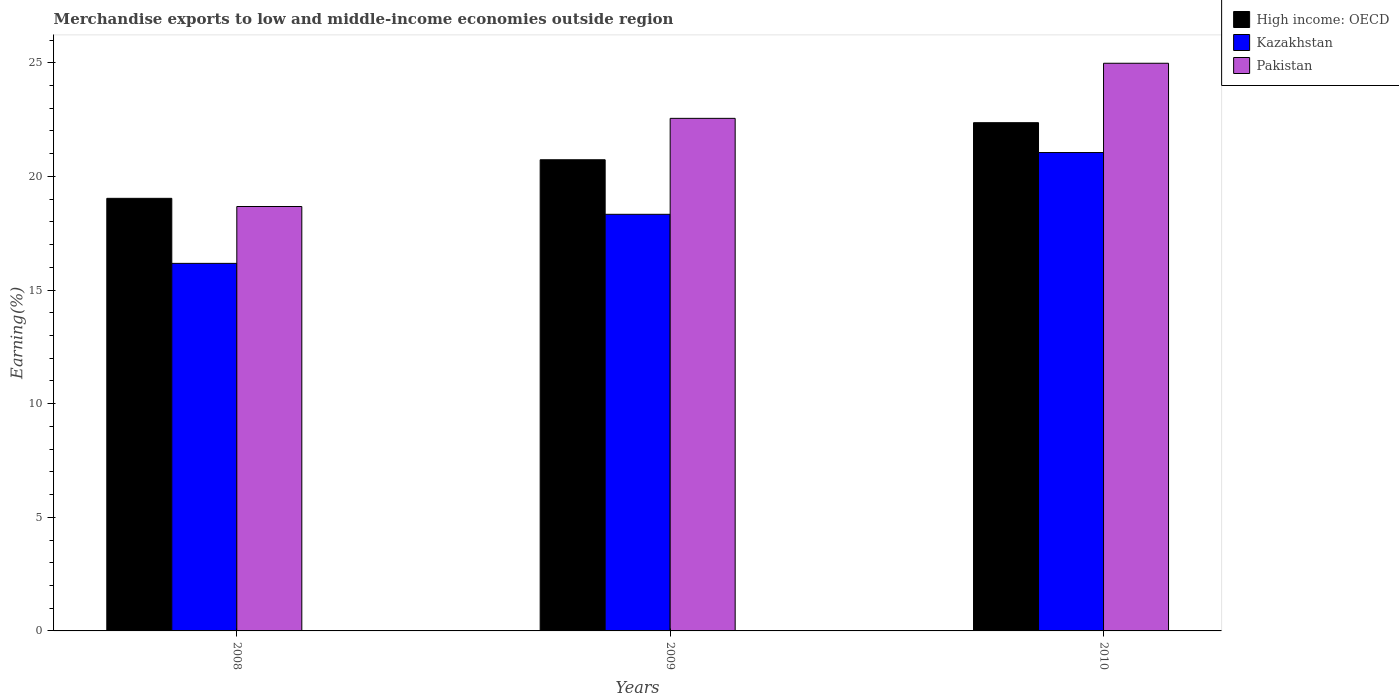How many different coloured bars are there?
Offer a terse response. 3. What is the label of the 1st group of bars from the left?
Ensure brevity in your answer.  2008. In how many cases, is the number of bars for a given year not equal to the number of legend labels?
Offer a terse response. 0. What is the percentage of amount earned from merchandise exports in Kazakhstan in 2010?
Make the answer very short. 21.05. Across all years, what is the maximum percentage of amount earned from merchandise exports in Pakistan?
Offer a very short reply. 24.98. Across all years, what is the minimum percentage of amount earned from merchandise exports in Kazakhstan?
Offer a terse response. 16.17. In which year was the percentage of amount earned from merchandise exports in Kazakhstan maximum?
Your response must be concise. 2010. What is the total percentage of amount earned from merchandise exports in Pakistan in the graph?
Provide a short and direct response. 66.21. What is the difference between the percentage of amount earned from merchandise exports in Pakistan in 2008 and that in 2009?
Offer a very short reply. -3.88. What is the difference between the percentage of amount earned from merchandise exports in Pakistan in 2010 and the percentage of amount earned from merchandise exports in Kazakhstan in 2009?
Your answer should be compact. 6.65. What is the average percentage of amount earned from merchandise exports in Pakistan per year?
Provide a succinct answer. 22.07. In the year 2008, what is the difference between the percentage of amount earned from merchandise exports in Pakistan and percentage of amount earned from merchandise exports in High income: OECD?
Keep it short and to the point. -0.36. In how many years, is the percentage of amount earned from merchandise exports in High income: OECD greater than 9 %?
Provide a succinct answer. 3. What is the ratio of the percentage of amount earned from merchandise exports in High income: OECD in 2009 to that in 2010?
Offer a terse response. 0.93. Is the percentage of amount earned from merchandise exports in High income: OECD in 2008 less than that in 2010?
Make the answer very short. Yes. What is the difference between the highest and the second highest percentage of amount earned from merchandise exports in Pakistan?
Your response must be concise. 2.42. What is the difference between the highest and the lowest percentage of amount earned from merchandise exports in High income: OECD?
Make the answer very short. 3.33. In how many years, is the percentage of amount earned from merchandise exports in Pakistan greater than the average percentage of amount earned from merchandise exports in Pakistan taken over all years?
Keep it short and to the point. 2. What does the 2nd bar from the left in 2010 represents?
Provide a short and direct response. Kazakhstan. What does the 3rd bar from the right in 2008 represents?
Your response must be concise. High income: OECD. How many bars are there?
Keep it short and to the point. 9. Are all the bars in the graph horizontal?
Offer a very short reply. No. How many years are there in the graph?
Keep it short and to the point. 3. Are the values on the major ticks of Y-axis written in scientific E-notation?
Your answer should be compact. No. Does the graph contain grids?
Your response must be concise. No. Where does the legend appear in the graph?
Offer a very short reply. Top right. How many legend labels are there?
Your answer should be compact. 3. What is the title of the graph?
Provide a short and direct response. Merchandise exports to low and middle-income economies outside region. What is the label or title of the Y-axis?
Make the answer very short. Earning(%). What is the Earning(%) of High income: OECD in 2008?
Your answer should be very brief. 19.04. What is the Earning(%) in Kazakhstan in 2008?
Keep it short and to the point. 16.17. What is the Earning(%) of Pakistan in 2008?
Offer a very short reply. 18.68. What is the Earning(%) in High income: OECD in 2009?
Make the answer very short. 20.73. What is the Earning(%) of Kazakhstan in 2009?
Offer a very short reply. 18.33. What is the Earning(%) of Pakistan in 2009?
Your response must be concise. 22.55. What is the Earning(%) in High income: OECD in 2010?
Your answer should be very brief. 22.36. What is the Earning(%) in Kazakhstan in 2010?
Your answer should be very brief. 21.05. What is the Earning(%) in Pakistan in 2010?
Offer a terse response. 24.98. Across all years, what is the maximum Earning(%) in High income: OECD?
Give a very brief answer. 22.36. Across all years, what is the maximum Earning(%) of Kazakhstan?
Provide a short and direct response. 21.05. Across all years, what is the maximum Earning(%) in Pakistan?
Your answer should be compact. 24.98. Across all years, what is the minimum Earning(%) of High income: OECD?
Provide a short and direct response. 19.04. Across all years, what is the minimum Earning(%) in Kazakhstan?
Offer a terse response. 16.17. Across all years, what is the minimum Earning(%) in Pakistan?
Give a very brief answer. 18.68. What is the total Earning(%) of High income: OECD in the graph?
Your answer should be very brief. 62.13. What is the total Earning(%) in Kazakhstan in the graph?
Offer a very short reply. 55.56. What is the total Earning(%) of Pakistan in the graph?
Your answer should be compact. 66.21. What is the difference between the Earning(%) of High income: OECD in 2008 and that in 2009?
Your answer should be compact. -1.7. What is the difference between the Earning(%) of Kazakhstan in 2008 and that in 2009?
Your answer should be very brief. -2.16. What is the difference between the Earning(%) in Pakistan in 2008 and that in 2009?
Provide a succinct answer. -3.88. What is the difference between the Earning(%) of High income: OECD in 2008 and that in 2010?
Offer a very short reply. -3.33. What is the difference between the Earning(%) of Kazakhstan in 2008 and that in 2010?
Your answer should be very brief. -4.88. What is the difference between the Earning(%) of Pakistan in 2008 and that in 2010?
Ensure brevity in your answer.  -6.3. What is the difference between the Earning(%) of High income: OECD in 2009 and that in 2010?
Make the answer very short. -1.63. What is the difference between the Earning(%) in Kazakhstan in 2009 and that in 2010?
Your answer should be compact. -2.72. What is the difference between the Earning(%) of Pakistan in 2009 and that in 2010?
Offer a very short reply. -2.42. What is the difference between the Earning(%) in High income: OECD in 2008 and the Earning(%) in Kazakhstan in 2009?
Provide a short and direct response. 0.7. What is the difference between the Earning(%) of High income: OECD in 2008 and the Earning(%) of Pakistan in 2009?
Keep it short and to the point. -3.52. What is the difference between the Earning(%) of Kazakhstan in 2008 and the Earning(%) of Pakistan in 2009?
Give a very brief answer. -6.38. What is the difference between the Earning(%) in High income: OECD in 2008 and the Earning(%) in Kazakhstan in 2010?
Ensure brevity in your answer.  -2.02. What is the difference between the Earning(%) of High income: OECD in 2008 and the Earning(%) of Pakistan in 2010?
Ensure brevity in your answer.  -5.94. What is the difference between the Earning(%) in Kazakhstan in 2008 and the Earning(%) in Pakistan in 2010?
Provide a short and direct response. -8.81. What is the difference between the Earning(%) in High income: OECD in 2009 and the Earning(%) in Kazakhstan in 2010?
Give a very brief answer. -0.32. What is the difference between the Earning(%) of High income: OECD in 2009 and the Earning(%) of Pakistan in 2010?
Offer a very short reply. -4.25. What is the difference between the Earning(%) of Kazakhstan in 2009 and the Earning(%) of Pakistan in 2010?
Ensure brevity in your answer.  -6.65. What is the average Earning(%) of High income: OECD per year?
Your answer should be very brief. 20.71. What is the average Earning(%) in Kazakhstan per year?
Provide a succinct answer. 18.52. What is the average Earning(%) in Pakistan per year?
Your response must be concise. 22.07. In the year 2008, what is the difference between the Earning(%) of High income: OECD and Earning(%) of Kazakhstan?
Your response must be concise. 2.86. In the year 2008, what is the difference between the Earning(%) in High income: OECD and Earning(%) in Pakistan?
Make the answer very short. 0.36. In the year 2008, what is the difference between the Earning(%) of Kazakhstan and Earning(%) of Pakistan?
Provide a short and direct response. -2.5. In the year 2009, what is the difference between the Earning(%) in High income: OECD and Earning(%) in Kazakhstan?
Provide a short and direct response. 2.4. In the year 2009, what is the difference between the Earning(%) in High income: OECD and Earning(%) in Pakistan?
Your response must be concise. -1.82. In the year 2009, what is the difference between the Earning(%) of Kazakhstan and Earning(%) of Pakistan?
Offer a terse response. -4.22. In the year 2010, what is the difference between the Earning(%) of High income: OECD and Earning(%) of Kazakhstan?
Ensure brevity in your answer.  1.31. In the year 2010, what is the difference between the Earning(%) of High income: OECD and Earning(%) of Pakistan?
Your response must be concise. -2.62. In the year 2010, what is the difference between the Earning(%) of Kazakhstan and Earning(%) of Pakistan?
Your answer should be compact. -3.93. What is the ratio of the Earning(%) of High income: OECD in 2008 to that in 2009?
Give a very brief answer. 0.92. What is the ratio of the Earning(%) in Kazakhstan in 2008 to that in 2009?
Offer a very short reply. 0.88. What is the ratio of the Earning(%) of Pakistan in 2008 to that in 2009?
Your answer should be compact. 0.83. What is the ratio of the Earning(%) in High income: OECD in 2008 to that in 2010?
Offer a very short reply. 0.85. What is the ratio of the Earning(%) of Kazakhstan in 2008 to that in 2010?
Give a very brief answer. 0.77. What is the ratio of the Earning(%) in Pakistan in 2008 to that in 2010?
Your answer should be compact. 0.75. What is the ratio of the Earning(%) of High income: OECD in 2009 to that in 2010?
Your response must be concise. 0.93. What is the ratio of the Earning(%) in Kazakhstan in 2009 to that in 2010?
Give a very brief answer. 0.87. What is the ratio of the Earning(%) in Pakistan in 2009 to that in 2010?
Your response must be concise. 0.9. What is the difference between the highest and the second highest Earning(%) in High income: OECD?
Offer a very short reply. 1.63. What is the difference between the highest and the second highest Earning(%) of Kazakhstan?
Keep it short and to the point. 2.72. What is the difference between the highest and the second highest Earning(%) in Pakistan?
Offer a terse response. 2.42. What is the difference between the highest and the lowest Earning(%) of High income: OECD?
Your answer should be compact. 3.33. What is the difference between the highest and the lowest Earning(%) of Kazakhstan?
Your answer should be compact. 4.88. What is the difference between the highest and the lowest Earning(%) of Pakistan?
Keep it short and to the point. 6.3. 